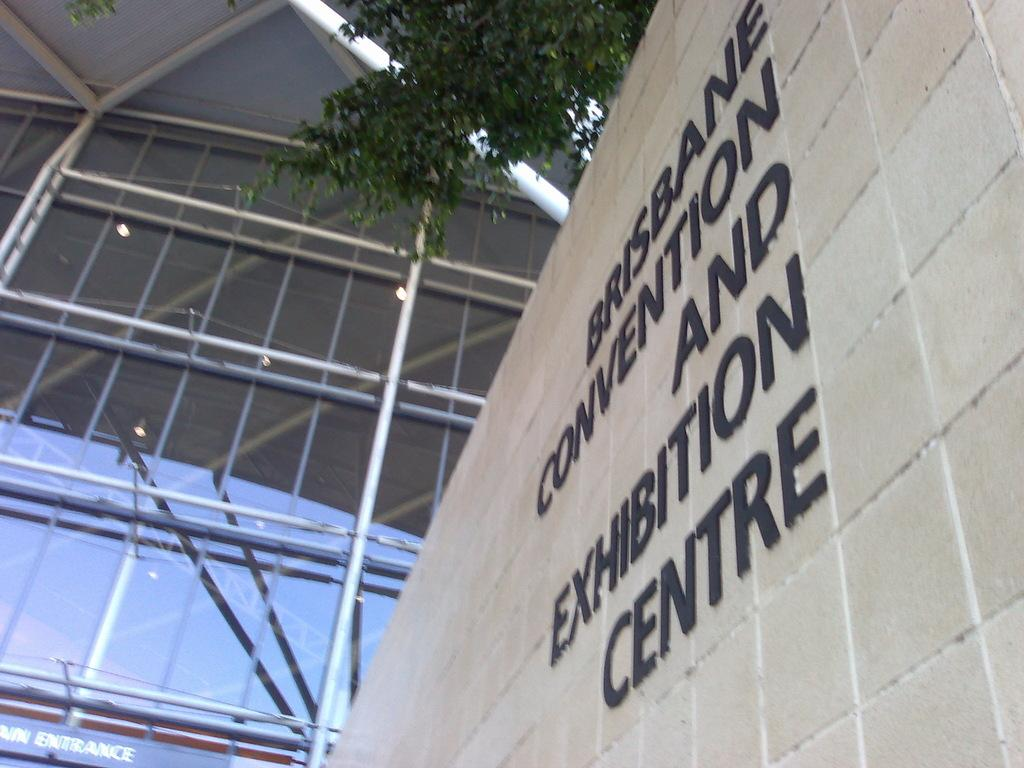What is written on the wall in the image? The facts do not specify the content of the writing on the wall. What color is the wall in the image? The wall is cream-colored. What can be seen in the background of the image? There is a glass window, rods, and plants in green color visible in the background of the image. How does the drain affect the vacation in the image? There is no drain or vacation mentioned in the image. What type of show is being performed in the background of the image? There is no show or performance taking place in the image. 